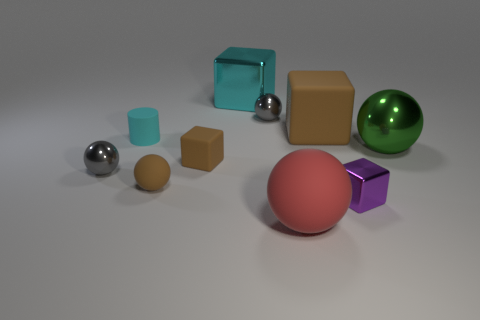Are there the same number of red objects on the right side of the tiny cyan thing and large purple cubes?
Offer a terse response. No. There is a red thing that is made of the same material as the tiny cyan cylinder; what is its shape?
Give a very brief answer. Sphere. Are there any small rubber balls that have the same color as the cylinder?
Keep it short and to the point. No. What number of shiny things are either small brown spheres or big yellow things?
Ensure brevity in your answer.  0. There is a brown matte object that is right of the big shiny block; how many cyan metal cubes are left of it?
Keep it short and to the point. 1. What number of purple things have the same material as the big cyan cube?
Offer a terse response. 1. How many small objects are either metallic cylinders or red spheres?
Give a very brief answer. 0. What shape is the shiny thing that is in front of the big green shiny thing and on the left side of the big rubber block?
Keep it short and to the point. Sphere. Do the large brown object and the red ball have the same material?
Ensure brevity in your answer.  Yes. What is the color of the matte block that is the same size as the cylinder?
Give a very brief answer. Brown. 